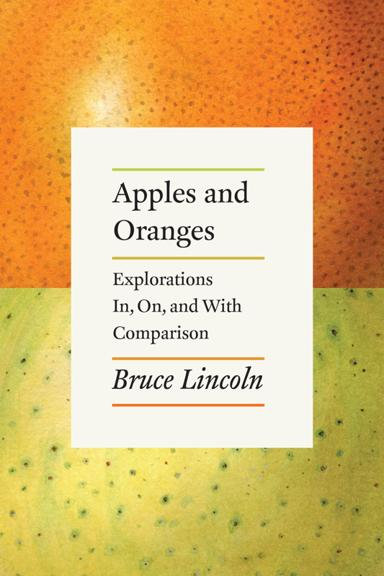Can you describe the design style used for the cover of this book? The design style of the book cover is minimalist and modern, utilizing a clean font for the title and author's name aligned to the center. The simplicity of the design may aim to draw attention to the content's depth rather than relying on elaborate graphics. 